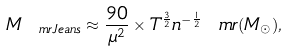<formula> <loc_0><loc_0><loc_500><loc_500>M _ { \ m r { J e a n s } } \approx \frac { 9 0 } { \mu ^ { 2 } } \times T ^ { \frac { 3 } { 2 } } n ^ { - \frac { 1 } { 2 } } \ m r { ( M _ { \odot } ) } ,</formula> 